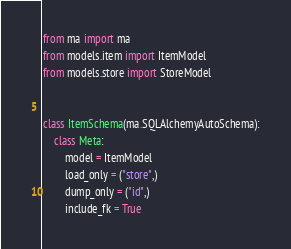<code> <loc_0><loc_0><loc_500><loc_500><_Python_>from ma import ma
from models.item import ItemModel
from models.store import StoreModel


class ItemSchema(ma.SQLAlchemyAutoSchema):
    class Meta:
        model = ItemModel
        load_only = ("store",)
        dump_only = ("id",)
        include_fk = True
</code> 